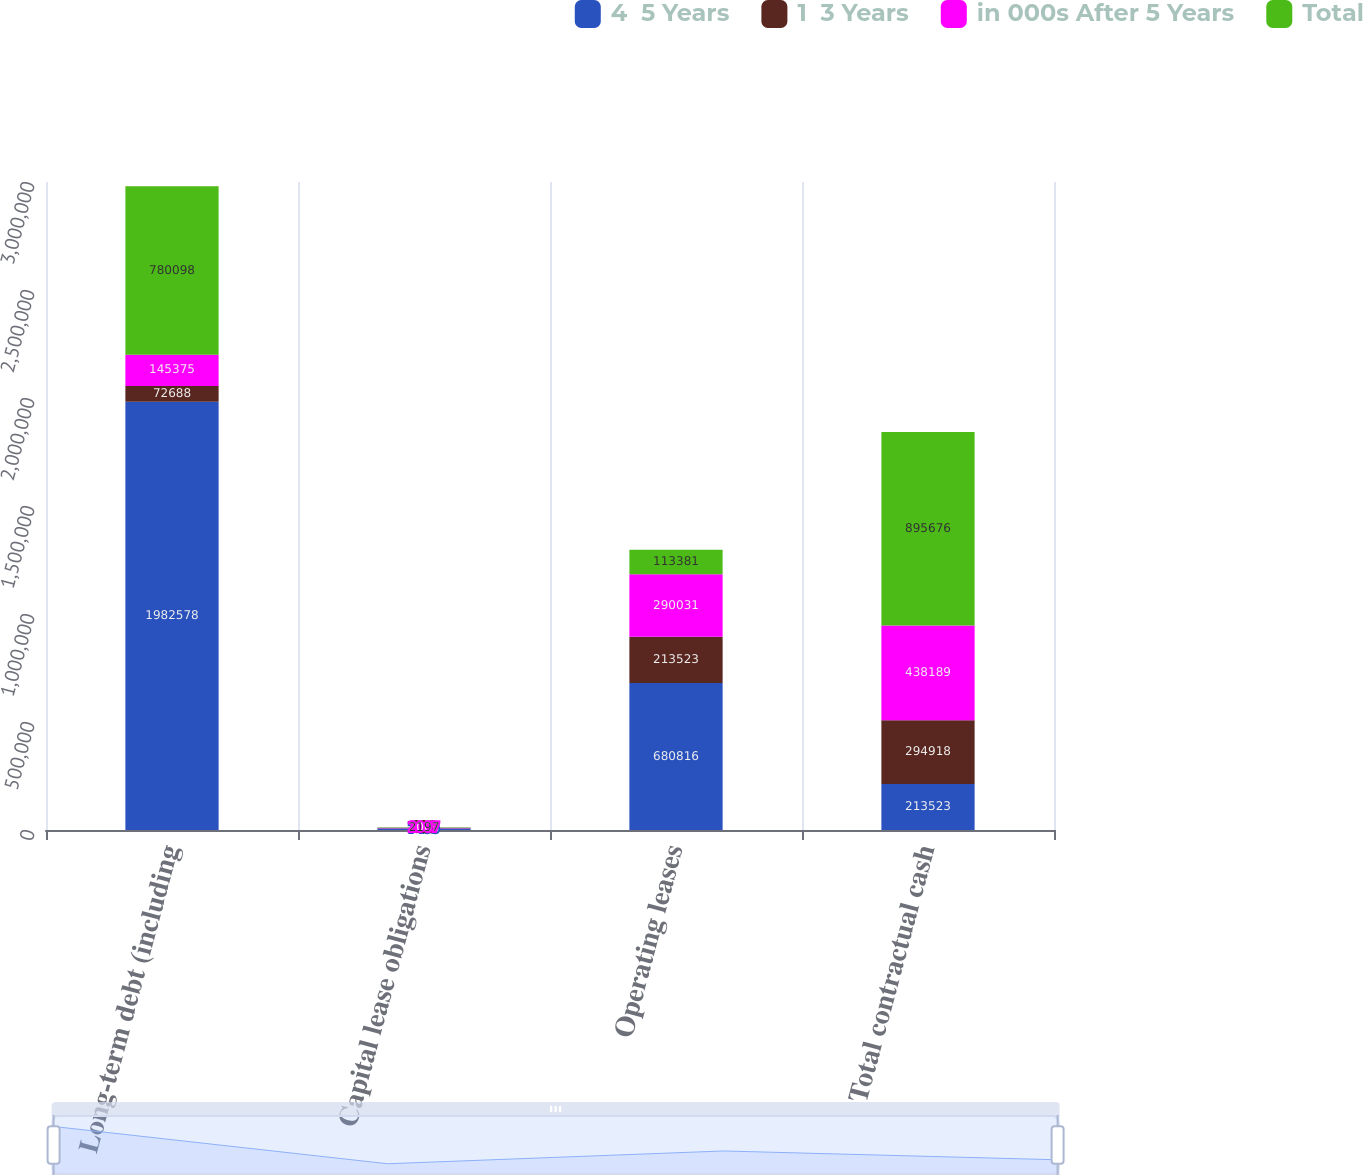<chart> <loc_0><loc_0><loc_500><loc_500><stacked_bar_chart><ecel><fcel>Long-term debt (including<fcel>Capital lease obligations<fcel>Operating leases<fcel>Total contractual cash<nl><fcel>4  5 Years<fcel>1.98258e+06<fcel>7435<fcel>680816<fcel>213523<nl><fcel>1  3 Years<fcel>72688<fcel>826<fcel>213523<fcel>294918<nl><fcel>in 000s After 5 Years<fcel>145375<fcel>2007<fcel>290031<fcel>438189<nl><fcel>Total<fcel>780098<fcel>2197<fcel>113381<fcel>895676<nl></chart> 